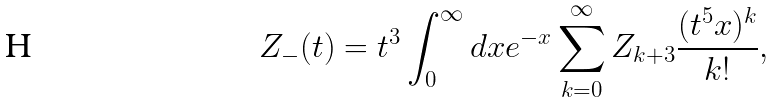<formula> <loc_0><loc_0><loc_500><loc_500>Z _ { - } ( t ) = t ^ { 3 } \int _ { 0 } ^ { \infty } d x e ^ { - x } \sum _ { k = 0 } ^ { \infty } Z _ { k + 3 } \frac { ( t ^ { 5 } x ) ^ { k } } { k ! } ,</formula> 